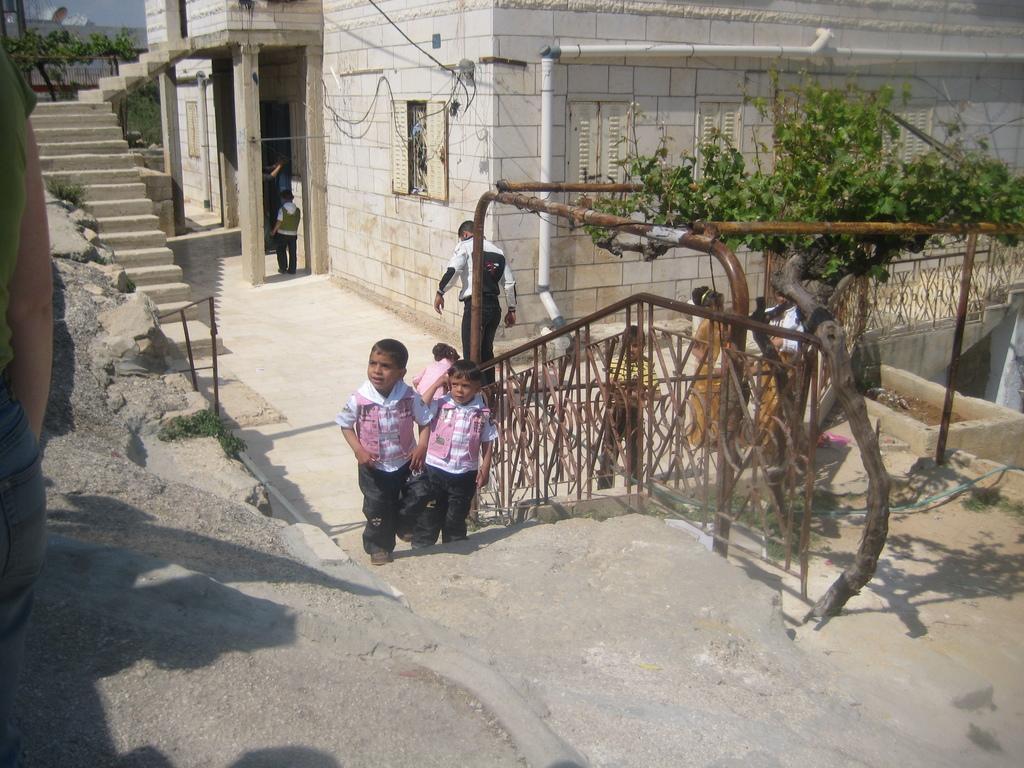Can you describe this image briefly? In this picture I can see there are few kids climbing the stairs, there is a man in the backdrop and there is a woman onto left and there is a building, plant and there are few stairs in the backdrop. 